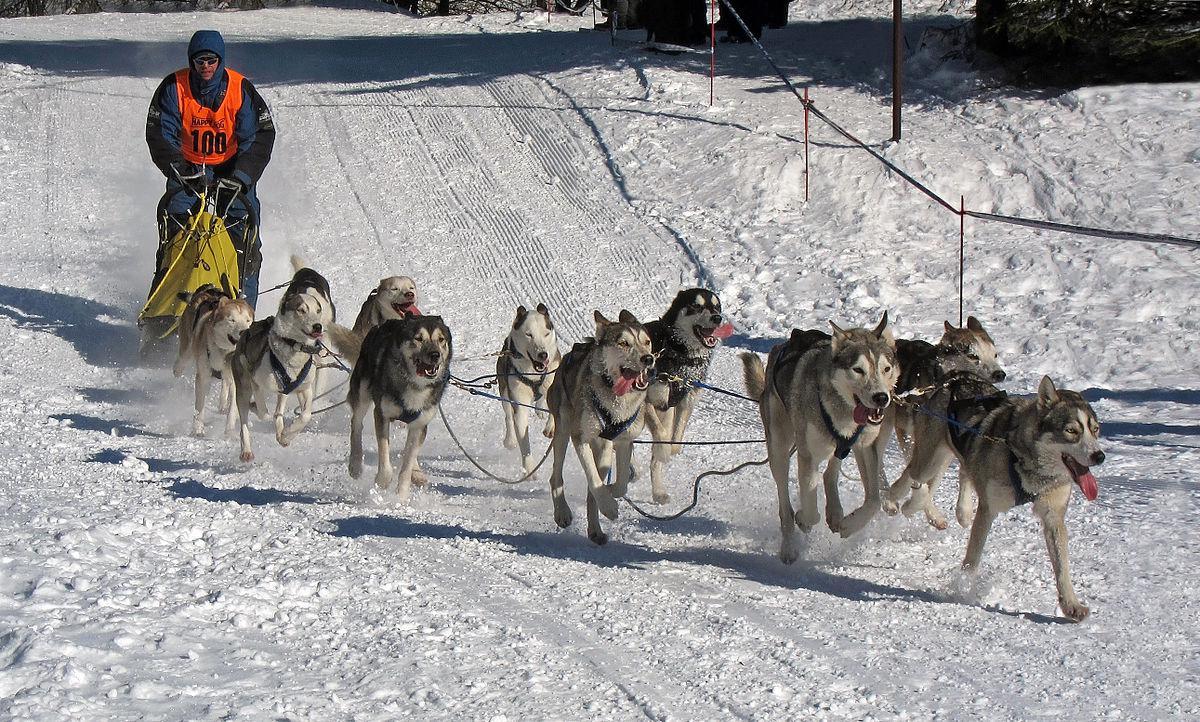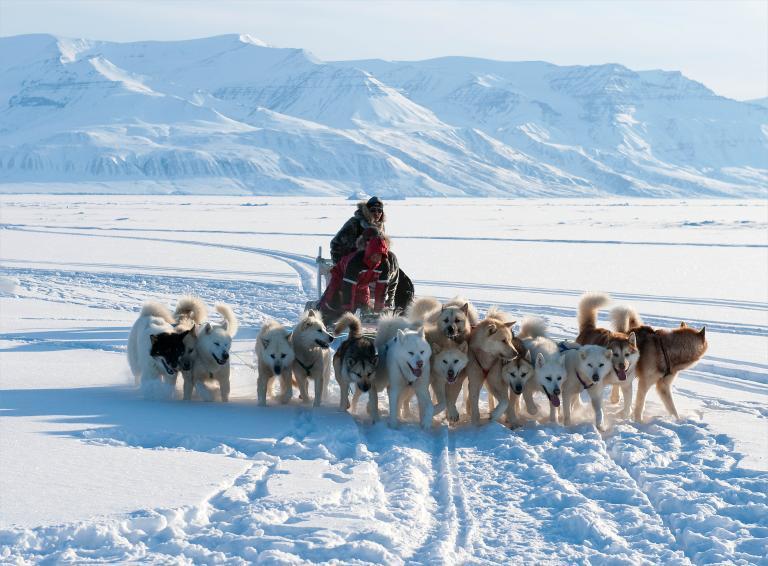The first image is the image on the left, the second image is the image on the right. For the images displayed, is the sentence "At least one of the images features six or less dogs pulling a sled." factually correct? Answer yes or no. No. The first image is the image on the left, the second image is the image on the right. Analyze the images presented: Is the assertion "Right image shows a sled dog team with a mountain range behind them." valid? Answer yes or no. Yes. 